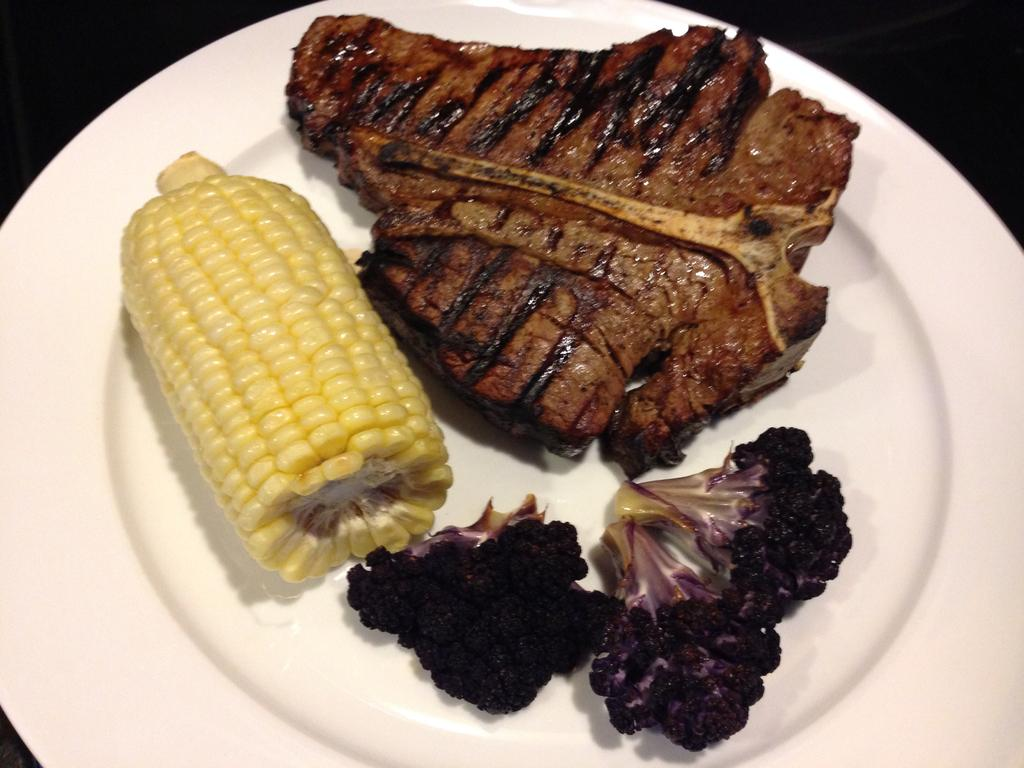What is on the plate that is visible in the image? There is meat, vegetables, and corn on the plate in the image. What type of food is not present on the plate? There is no mention of snail or sticks on the plate in the image. What can be inferred about the meal from the items on the plate? The plate contains a balanced meal with meat, vegetables, and corn. Did the earthquake cause the corn to fall off the plate in the image? There is no earthquake or any indication of disturbance in the image; the plate and its contents appear to be undisturbed. 